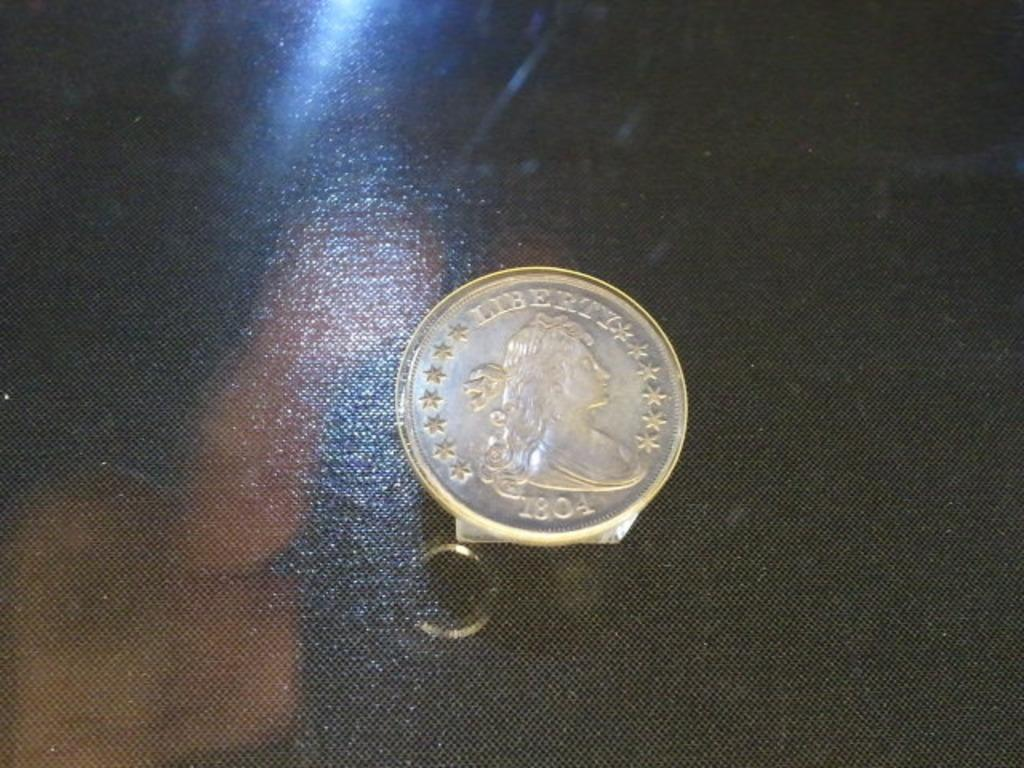<image>
Give a short and clear explanation of the subsequent image. A silver Liberty coin from 1804 on a table 